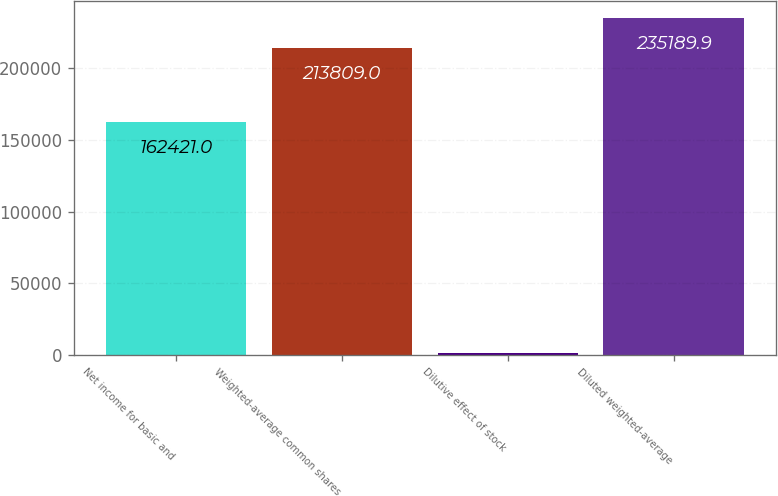Convert chart. <chart><loc_0><loc_0><loc_500><loc_500><bar_chart><fcel>Net income for basic and<fcel>Weighted-average common shares<fcel>Dilutive effect of stock<fcel>Diluted weighted-average<nl><fcel>162421<fcel>213809<fcel>1486<fcel>235190<nl></chart> 